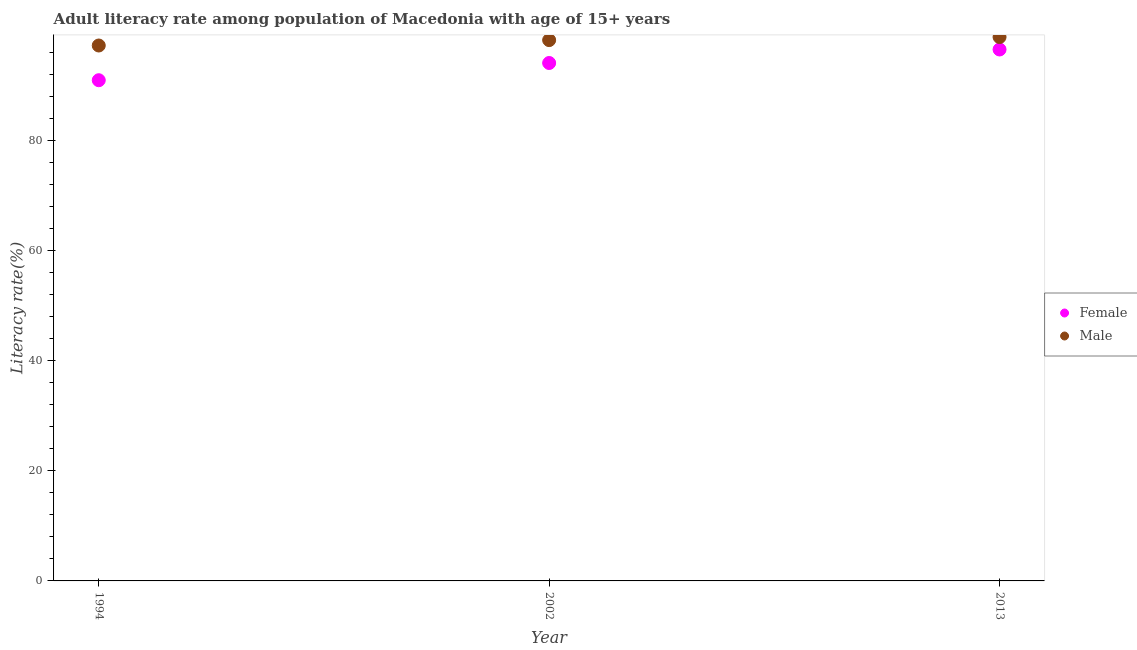Is the number of dotlines equal to the number of legend labels?
Your answer should be compact. Yes. What is the female adult literacy rate in 2002?
Make the answer very short. 94.06. Across all years, what is the maximum female adult literacy rate?
Your answer should be very brief. 96.51. Across all years, what is the minimum male adult literacy rate?
Your answer should be compact. 97.23. In which year was the male adult literacy rate maximum?
Give a very brief answer. 2013. What is the total female adult literacy rate in the graph?
Provide a succinct answer. 281.49. What is the difference between the male adult literacy rate in 1994 and that in 2002?
Keep it short and to the point. -0.98. What is the difference between the male adult literacy rate in 1994 and the female adult literacy rate in 2013?
Provide a short and direct response. 0.72. What is the average female adult literacy rate per year?
Ensure brevity in your answer.  93.83. In the year 1994, what is the difference between the male adult literacy rate and female adult literacy rate?
Offer a very short reply. 6.3. In how many years, is the male adult literacy rate greater than 52 %?
Your answer should be compact. 3. What is the ratio of the male adult literacy rate in 1994 to that in 2002?
Your answer should be compact. 0.99. Is the difference between the female adult literacy rate in 1994 and 2013 greater than the difference between the male adult literacy rate in 1994 and 2013?
Offer a terse response. No. What is the difference between the highest and the second highest female adult literacy rate?
Ensure brevity in your answer.  2.45. What is the difference between the highest and the lowest male adult literacy rate?
Offer a terse response. 1.54. Does the male adult literacy rate monotonically increase over the years?
Your answer should be very brief. Yes. Is the male adult literacy rate strictly greater than the female adult literacy rate over the years?
Provide a short and direct response. Yes. Is the male adult literacy rate strictly less than the female adult literacy rate over the years?
Keep it short and to the point. No. How many years are there in the graph?
Provide a short and direct response. 3. Does the graph contain grids?
Offer a terse response. No. How many legend labels are there?
Ensure brevity in your answer.  2. How are the legend labels stacked?
Offer a terse response. Vertical. What is the title of the graph?
Your answer should be compact. Adult literacy rate among population of Macedonia with age of 15+ years. What is the label or title of the X-axis?
Your answer should be compact. Year. What is the label or title of the Y-axis?
Give a very brief answer. Literacy rate(%). What is the Literacy rate(%) of Female in 1994?
Give a very brief answer. 90.93. What is the Literacy rate(%) of Male in 1994?
Ensure brevity in your answer.  97.23. What is the Literacy rate(%) in Female in 2002?
Your response must be concise. 94.06. What is the Literacy rate(%) in Male in 2002?
Provide a short and direct response. 98.21. What is the Literacy rate(%) in Female in 2013?
Your response must be concise. 96.51. What is the Literacy rate(%) of Male in 2013?
Ensure brevity in your answer.  98.77. Across all years, what is the maximum Literacy rate(%) in Female?
Give a very brief answer. 96.51. Across all years, what is the maximum Literacy rate(%) in Male?
Provide a succinct answer. 98.77. Across all years, what is the minimum Literacy rate(%) in Female?
Give a very brief answer. 90.93. Across all years, what is the minimum Literacy rate(%) of Male?
Provide a succinct answer. 97.23. What is the total Literacy rate(%) of Female in the graph?
Provide a succinct answer. 281.49. What is the total Literacy rate(%) in Male in the graph?
Your response must be concise. 294.22. What is the difference between the Literacy rate(%) in Female in 1994 and that in 2002?
Offer a very short reply. -3.13. What is the difference between the Literacy rate(%) in Male in 1994 and that in 2002?
Ensure brevity in your answer.  -0.98. What is the difference between the Literacy rate(%) in Female in 1994 and that in 2013?
Keep it short and to the point. -5.58. What is the difference between the Literacy rate(%) of Male in 1994 and that in 2013?
Provide a short and direct response. -1.54. What is the difference between the Literacy rate(%) in Female in 2002 and that in 2013?
Give a very brief answer. -2.45. What is the difference between the Literacy rate(%) in Male in 2002 and that in 2013?
Ensure brevity in your answer.  -0.56. What is the difference between the Literacy rate(%) in Female in 1994 and the Literacy rate(%) in Male in 2002?
Give a very brief answer. -7.28. What is the difference between the Literacy rate(%) in Female in 1994 and the Literacy rate(%) in Male in 2013?
Your response must be concise. -7.84. What is the difference between the Literacy rate(%) in Female in 2002 and the Literacy rate(%) in Male in 2013?
Provide a succinct answer. -4.71. What is the average Literacy rate(%) in Female per year?
Ensure brevity in your answer.  93.83. What is the average Literacy rate(%) in Male per year?
Your answer should be compact. 98.07. In the year 1994, what is the difference between the Literacy rate(%) of Female and Literacy rate(%) of Male?
Make the answer very short. -6.3. In the year 2002, what is the difference between the Literacy rate(%) of Female and Literacy rate(%) of Male?
Your response must be concise. -4.16. In the year 2013, what is the difference between the Literacy rate(%) of Female and Literacy rate(%) of Male?
Your answer should be very brief. -2.26. What is the ratio of the Literacy rate(%) in Female in 1994 to that in 2002?
Provide a succinct answer. 0.97. What is the ratio of the Literacy rate(%) in Male in 1994 to that in 2002?
Make the answer very short. 0.99. What is the ratio of the Literacy rate(%) of Female in 1994 to that in 2013?
Provide a short and direct response. 0.94. What is the ratio of the Literacy rate(%) in Male in 1994 to that in 2013?
Keep it short and to the point. 0.98. What is the ratio of the Literacy rate(%) of Female in 2002 to that in 2013?
Keep it short and to the point. 0.97. What is the ratio of the Literacy rate(%) in Male in 2002 to that in 2013?
Keep it short and to the point. 0.99. What is the difference between the highest and the second highest Literacy rate(%) in Female?
Your response must be concise. 2.45. What is the difference between the highest and the second highest Literacy rate(%) in Male?
Ensure brevity in your answer.  0.56. What is the difference between the highest and the lowest Literacy rate(%) of Female?
Your answer should be compact. 5.58. What is the difference between the highest and the lowest Literacy rate(%) in Male?
Ensure brevity in your answer.  1.54. 